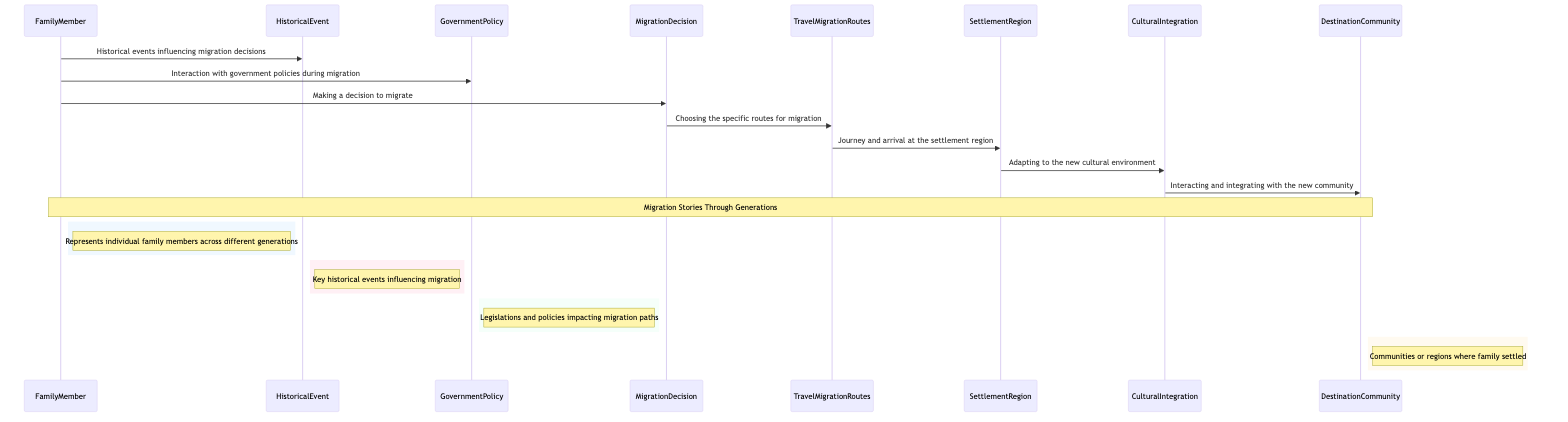What is the first interaction for the FamilyMember? The FamilyMember first interacts with the HistoricalEvent, indicating that historical factors influence their migration decisions.
Answer: HistoricalEvent How many actors are represented in the diagram? The diagram contains four main actors: FamilyMember, HistoricalEvent, GovernmentPolicy, and DestinationCommunity.
Answer: Four What is the last interaction shown in the diagram? The last interaction is between CulturalIntegration and DestinationCommunity, which signifies the integration with the new community.
Answer: Interacting and integrating with the new community Which object comes immediately after MigrationDecision in the flow? After the MigrationDecision, the next object is TravelMigrationRoutes, representing the chosen paths for migration.
Answer: TravelMigrationRoutes What kind of area does SettlementRegion represent? SettlementRegion signifies the area where the family settles after their migration journey.
Answer: Region where family settled What influences the FamilyMember's MigrationDecision? The MigrationDecision is influenced by both the HistoricalEvent and GovernmentPolicy that provide context and constraints during the decision-making process.
Answer: HistoricalEvent and GovernmentPolicy Which step follows the TravelMigrationRoutes? The step that follows TravelMigrationRoutes is the arrival at the SettlementRegion, indicating the completion of the journey.
Answer: SettlementRegion Which actor represents the legislation impacting migration? The GovernmentPolicy actor represents the various legislations and policies that impact migration paths.
Answer: GovernmentPolicy What does CulturalIntegration lead to? CulturalIntegration leads to interaction with the DestinationCommunity, indicating the process of becoming part of a new community.
Answer: DestinationCommunity 